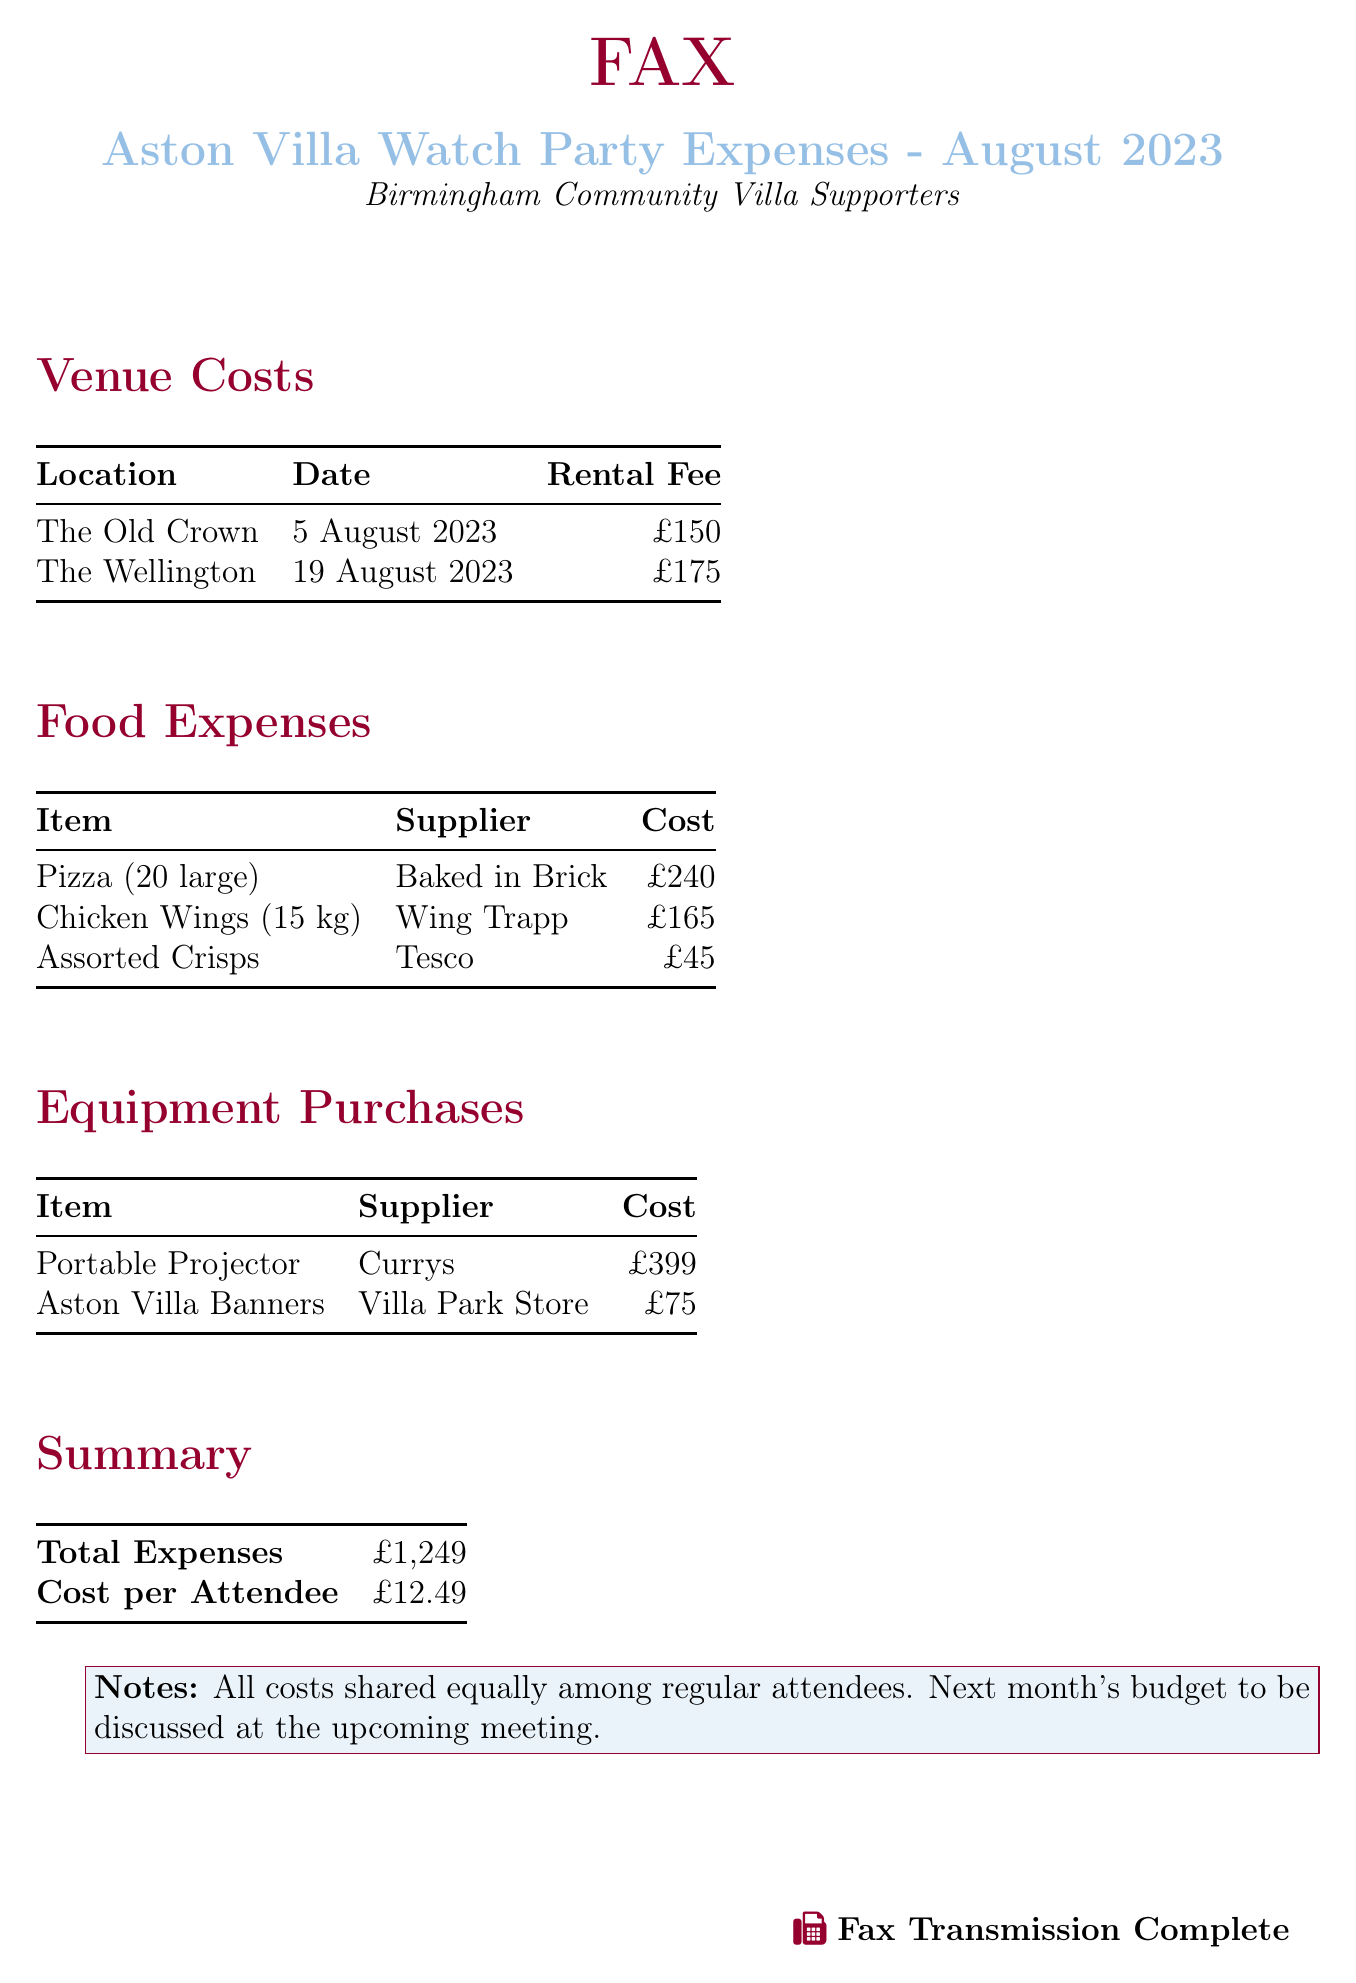what was the rental fee for The Old Crown? The rental fee for The Old Crown is listed in the venue costs section of the document.
Answer: £150 how much did the Chicken Wings cost? The cost of the Chicken Wings can be found under food expenses in the document.
Answer: £165 what is the total expense for the watch parties? The total expenses are summarized at the end of the document.
Answer: £1,249 how many large pizzas were purchased? The number of large pizzas is mentioned in the food expenses section.
Answer: 20 large what was the cost per attendee? The cost per attendee is calculated based on the total expenses in the summary section.
Answer: £12.49 which supplier provided the Assorted Crisps? The supplier for Assorted Crisps can be found in the food expenses table.
Answer: Tesco how many venues were rented in August 2023? The number of venues rented can be counted from the venue costs section.
Answer: 2 what was the cost of the Portable Projector? The cost of the Portable Projector is specified in the equipment purchases section.
Answer: £399 what is the color theme of the document? The color theme of the document is indicated by the defined colors at the beginning of the document.
Answer: Villaclaret and Villablue 